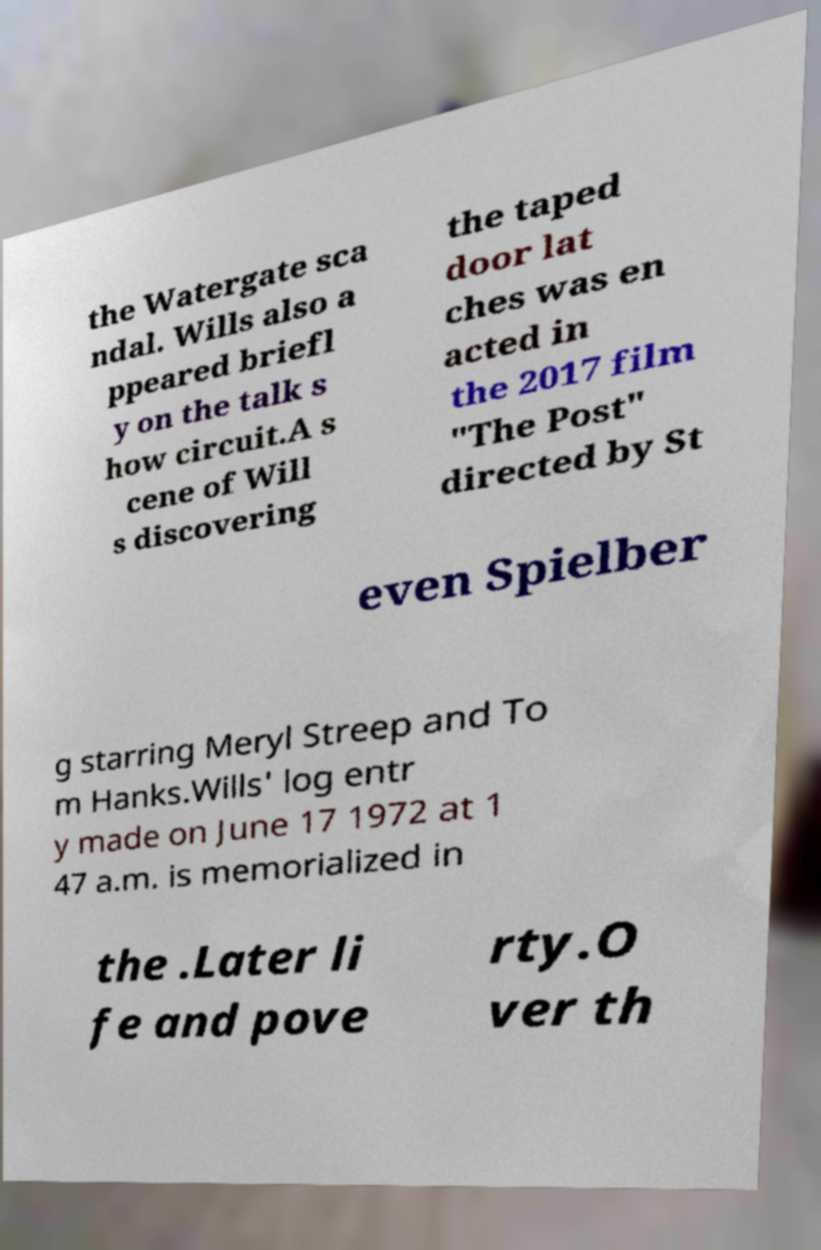There's text embedded in this image that I need extracted. Can you transcribe it verbatim? the Watergate sca ndal. Wills also a ppeared briefl y on the talk s how circuit.A s cene of Will s discovering the taped door lat ches was en acted in the 2017 film "The Post" directed by St even Spielber g starring Meryl Streep and To m Hanks.Wills' log entr y made on June 17 1972 at 1 47 a.m. is memorialized in the .Later li fe and pove rty.O ver th 